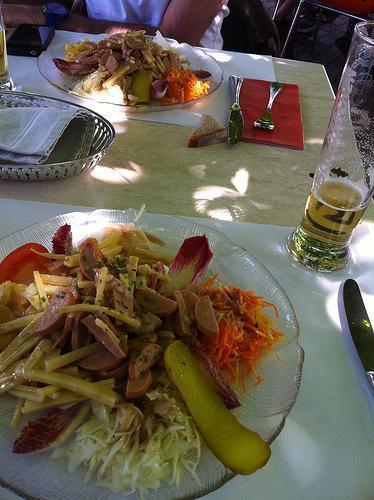How many full glasses are there?
Give a very brief answer. 0. 